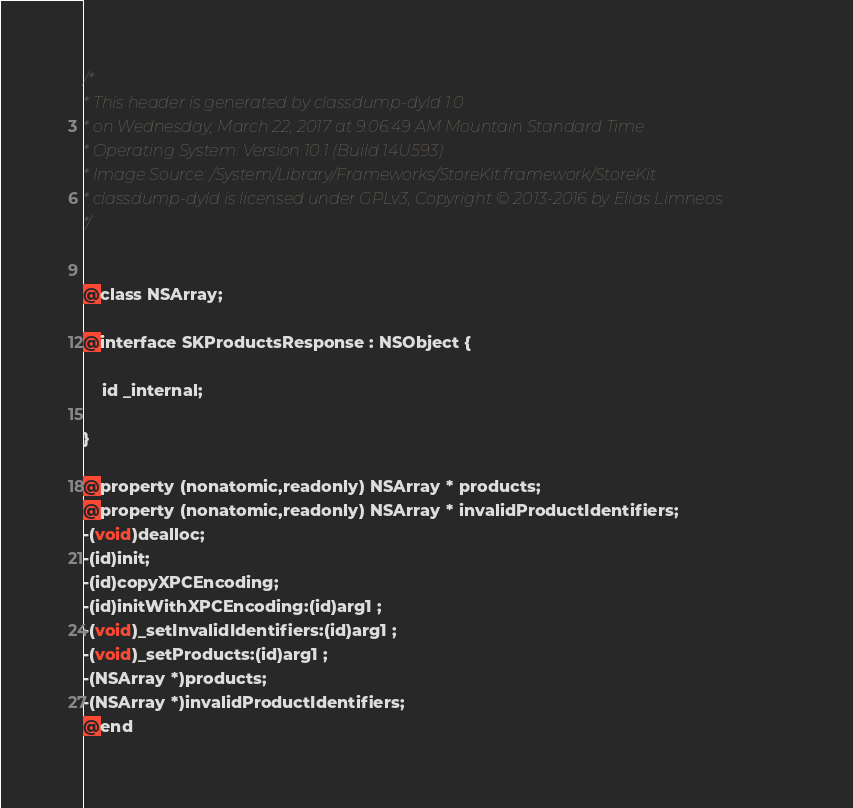<code> <loc_0><loc_0><loc_500><loc_500><_C_>/*
* This header is generated by classdump-dyld 1.0
* on Wednesday, March 22, 2017 at 9:06:49 AM Mountain Standard Time
* Operating System: Version 10.1 (Build 14U593)
* Image Source: /System/Library/Frameworks/StoreKit.framework/StoreKit
* classdump-dyld is licensed under GPLv3, Copyright © 2013-2016 by Elias Limneos.
*/


@class NSArray;

@interface SKProductsResponse : NSObject {

	id _internal;

}

@property (nonatomic,readonly) NSArray * products; 
@property (nonatomic,readonly) NSArray * invalidProductIdentifiers; 
-(void)dealloc;
-(id)init;
-(id)copyXPCEncoding;
-(id)initWithXPCEncoding:(id)arg1 ;
-(void)_setInvalidIdentifiers:(id)arg1 ;
-(void)_setProducts:(id)arg1 ;
-(NSArray *)products;
-(NSArray *)invalidProductIdentifiers;
@end

</code> 